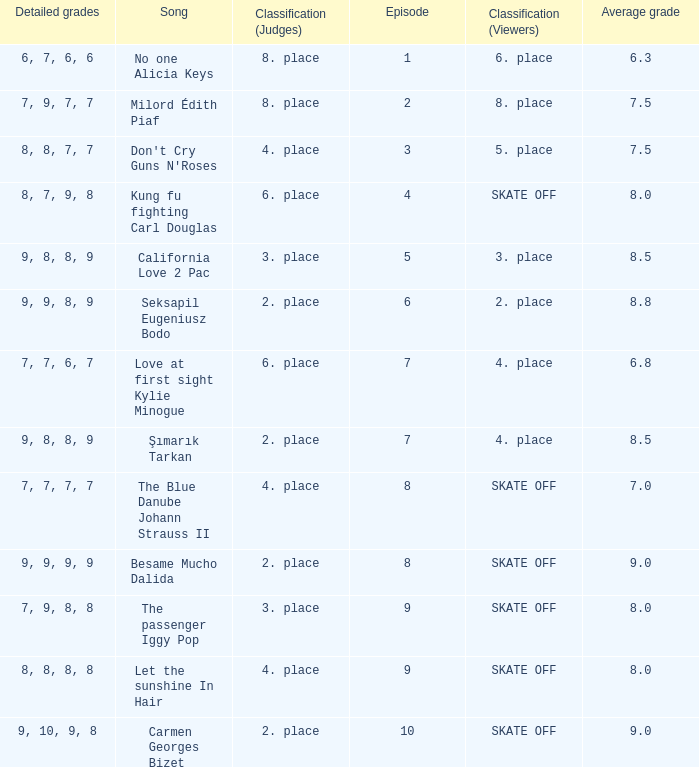Name the classification for 9, 9, 8, 9 2. place. 